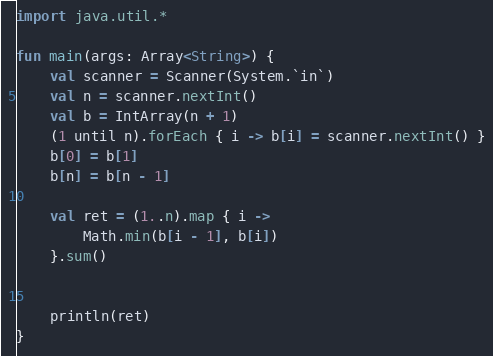Convert code to text. <code><loc_0><loc_0><loc_500><loc_500><_Kotlin_>import java.util.*

fun main(args: Array<String>) {
    val scanner = Scanner(System.`in`)
    val n = scanner.nextInt()
    val b = IntArray(n + 1)
    (1 until n).forEach { i -> b[i] = scanner.nextInt() }
    b[0] = b[1]
    b[n] = b[n - 1]

    val ret = (1..n).map { i ->
        Math.min(b[i - 1], b[i])
    }.sum()


    println(ret)
}</code> 